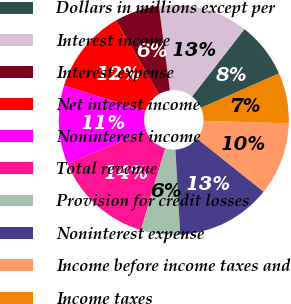Convert chart. <chart><loc_0><loc_0><loc_500><loc_500><pie_chart><fcel>Dollars in millions except per<fcel>Interest income<fcel>Interest expense<fcel>Net interest income<fcel>Noninterest income<fcel>Total revenue<fcel>Provision for credit losses<fcel>Noninterest expense<fcel>Income before income taxes and<fcel>Income taxes<nl><fcel>7.87%<fcel>12.6%<fcel>6.3%<fcel>11.81%<fcel>11.02%<fcel>14.17%<fcel>5.51%<fcel>13.39%<fcel>10.24%<fcel>7.09%<nl></chart> 